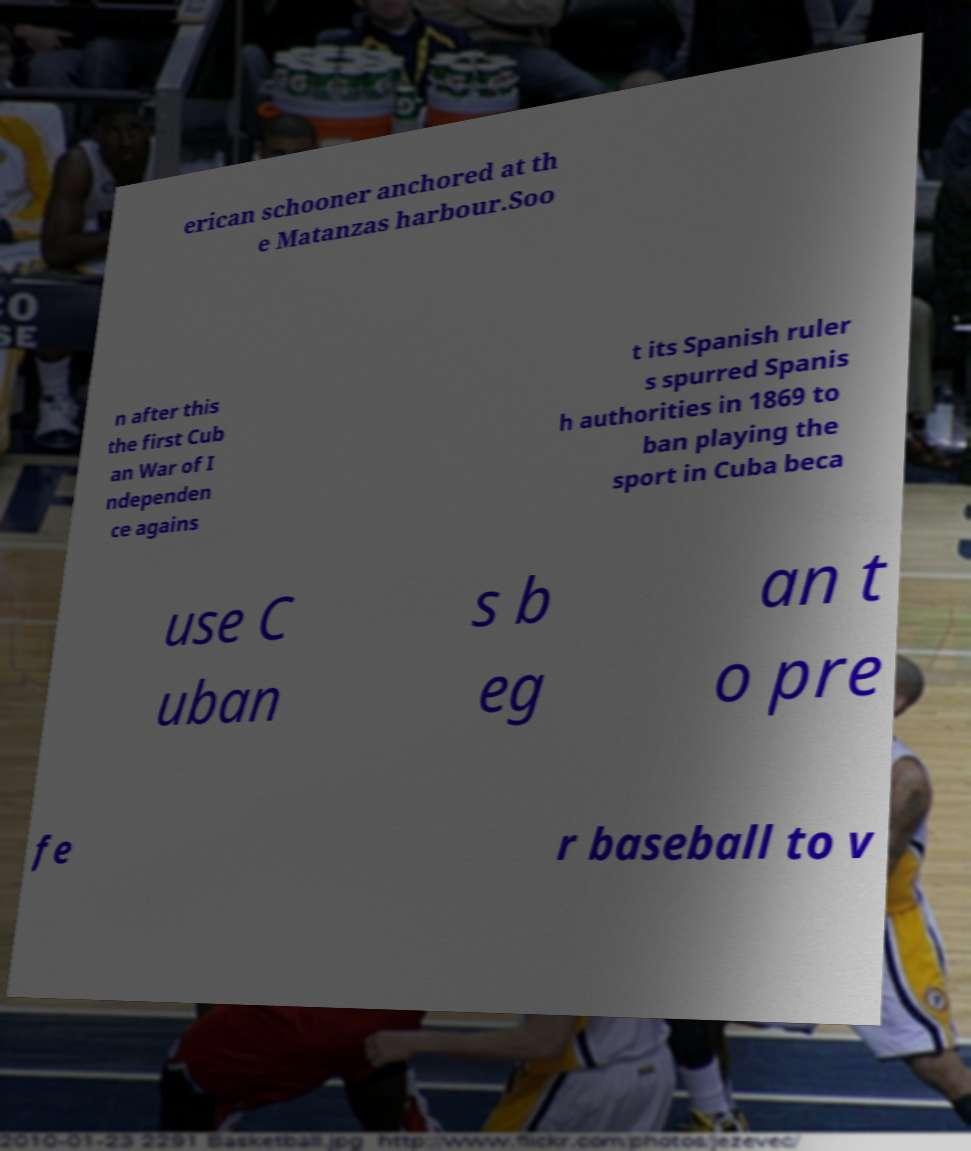For documentation purposes, I need the text within this image transcribed. Could you provide that? erican schooner anchored at th e Matanzas harbour.Soo n after this the first Cub an War of I ndependen ce agains t its Spanish ruler s spurred Spanis h authorities in 1869 to ban playing the sport in Cuba beca use C uban s b eg an t o pre fe r baseball to v 